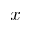Convert formula to latex. <formula><loc_0><loc_0><loc_500><loc_500>x</formula> 